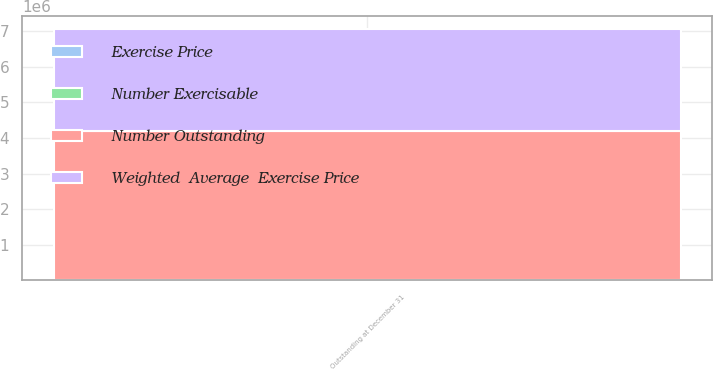Convert chart. <chart><loc_0><loc_0><loc_500><loc_500><stacked_bar_chart><ecel><fcel>Outstanding at December 31<nl><fcel>Number Outstanding<fcel>4.19422e+06<nl><fcel>Number Exercisable<fcel>33.38<nl><fcel>Weighted  Average  Exercise Price<fcel>2.87194e+06<nl><fcel>Exercise Price<fcel>32.84<nl></chart> 